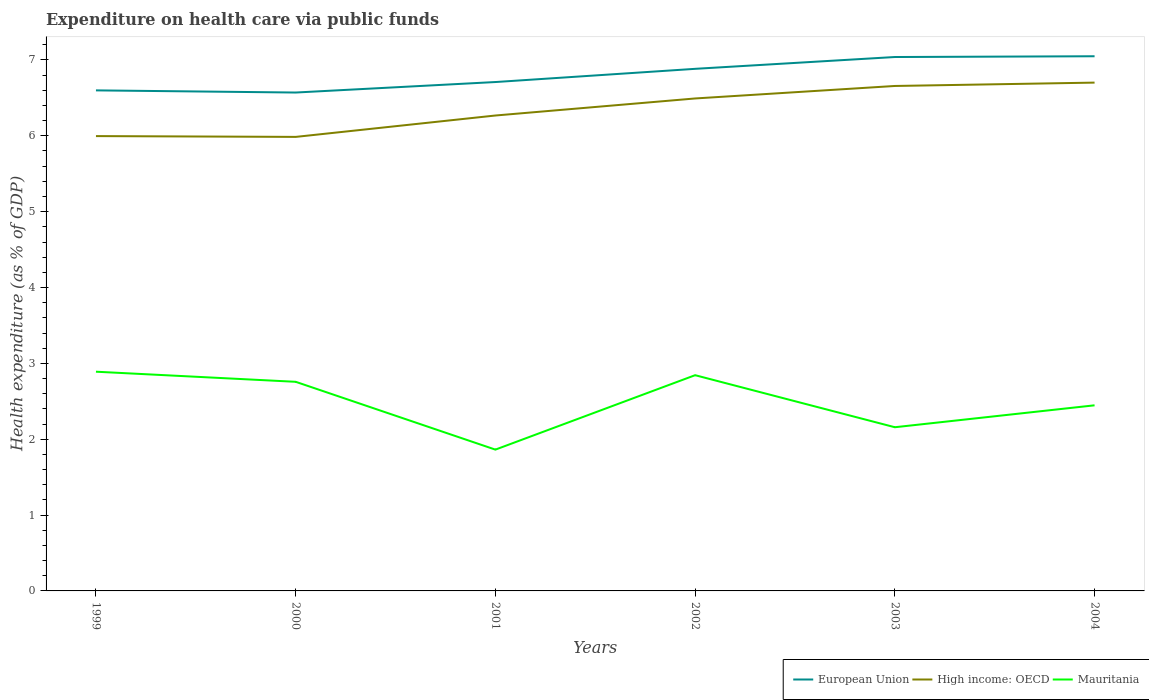How many different coloured lines are there?
Make the answer very short. 3. Does the line corresponding to Mauritania intersect with the line corresponding to European Union?
Provide a short and direct response. No. Across all years, what is the maximum expenditure made on health care in Mauritania?
Ensure brevity in your answer.  1.86. In which year was the expenditure made on health care in Mauritania maximum?
Your answer should be compact. 2001. What is the total expenditure made on health care in Mauritania in the graph?
Offer a terse response. 0.4. What is the difference between the highest and the second highest expenditure made on health care in European Union?
Provide a succinct answer. 0.48. Is the expenditure made on health care in High income: OECD strictly greater than the expenditure made on health care in Mauritania over the years?
Your response must be concise. No. How many years are there in the graph?
Make the answer very short. 6. What is the difference between two consecutive major ticks on the Y-axis?
Your response must be concise. 1. Are the values on the major ticks of Y-axis written in scientific E-notation?
Ensure brevity in your answer.  No. How many legend labels are there?
Keep it short and to the point. 3. How are the legend labels stacked?
Make the answer very short. Horizontal. What is the title of the graph?
Give a very brief answer. Expenditure on health care via public funds. What is the label or title of the Y-axis?
Your answer should be very brief. Health expenditure (as % of GDP). What is the Health expenditure (as % of GDP) of European Union in 1999?
Your answer should be very brief. 6.6. What is the Health expenditure (as % of GDP) of High income: OECD in 1999?
Your answer should be very brief. 6. What is the Health expenditure (as % of GDP) of Mauritania in 1999?
Offer a terse response. 2.89. What is the Health expenditure (as % of GDP) in European Union in 2000?
Your answer should be compact. 6.57. What is the Health expenditure (as % of GDP) in High income: OECD in 2000?
Offer a very short reply. 5.99. What is the Health expenditure (as % of GDP) in Mauritania in 2000?
Make the answer very short. 2.76. What is the Health expenditure (as % of GDP) in European Union in 2001?
Ensure brevity in your answer.  6.71. What is the Health expenditure (as % of GDP) of High income: OECD in 2001?
Make the answer very short. 6.27. What is the Health expenditure (as % of GDP) in Mauritania in 2001?
Offer a terse response. 1.86. What is the Health expenditure (as % of GDP) of European Union in 2002?
Make the answer very short. 6.88. What is the Health expenditure (as % of GDP) in High income: OECD in 2002?
Your response must be concise. 6.49. What is the Health expenditure (as % of GDP) in Mauritania in 2002?
Your answer should be compact. 2.84. What is the Health expenditure (as % of GDP) of European Union in 2003?
Provide a succinct answer. 7.04. What is the Health expenditure (as % of GDP) in High income: OECD in 2003?
Your response must be concise. 6.66. What is the Health expenditure (as % of GDP) in Mauritania in 2003?
Provide a short and direct response. 2.16. What is the Health expenditure (as % of GDP) in European Union in 2004?
Ensure brevity in your answer.  7.05. What is the Health expenditure (as % of GDP) in High income: OECD in 2004?
Offer a very short reply. 6.7. What is the Health expenditure (as % of GDP) of Mauritania in 2004?
Give a very brief answer. 2.45. Across all years, what is the maximum Health expenditure (as % of GDP) of European Union?
Your response must be concise. 7.05. Across all years, what is the maximum Health expenditure (as % of GDP) of High income: OECD?
Your answer should be very brief. 6.7. Across all years, what is the maximum Health expenditure (as % of GDP) in Mauritania?
Offer a very short reply. 2.89. Across all years, what is the minimum Health expenditure (as % of GDP) of European Union?
Offer a terse response. 6.57. Across all years, what is the minimum Health expenditure (as % of GDP) of High income: OECD?
Give a very brief answer. 5.99. Across all years, what is the minimum Health expenditure (as % of GDP) in Mauritania?
Provide a succinct answer. 1.86. What is the total Health expenditure (as % of GDP) in European Union in the graph?
Your response must be concise. 40.85. What is the total Health expenditure (as % of GDP) in High income: OECD in the graph?
Ensure brevity in your answer.  38.1. What is the total Health expenditure (as % of GDP) in Mauritania in the graph?
Ensure brevity in your answer.  14.96. What is the difference between the Health expenditure (as % of GDP) in European Union in 1999 and that in 2000?
Offer a terse response. 0.03. What is the difference between the Health expenditure (as % of GDP) of High income: OECD in 1999 and that in 2000?
Provide a succinct answer. 0.01. What is the difference between the Health expenditure (as % of GDP) of Mauritania in 1999 and that in 2000?
Give a very brief answer. 0.13. What is the difference between the Health expenditure (as % of GDP) of European Union in 1999 and that in 2001?
Offer a very short reply. -0.11. What is the difference between the Health expenditure (as % of GDP) in High income: OECD in 1999 and that in 2001?
Your answer should be compact. -0.27. What is the difference between the Health expenditure (as % of GDP) of Mauritania in 1999 and that in 2001?
Provide a short and direct response. 1.03. What is the difference between the Health expenditure (as % of GDP) in European Union in 1999 and that in 2002?
Offer a terse response. -0.28. What is the difference between the Health expenditure (as % of GDP) in High income: OECD in 1999 and that in 2002?
Your answer should be very brief. -0.5. What is the difference between the Health expenditure (as % of GDP) of Mauritania in 1999 and that in 2002?
Offer a terse response. 0.05. What is the difference between the Health expenditure (as % of GDP) of European Union in 1999 and that in 2003?
Your answer should be very brief. -0.44. What is the difference between the Health expenditure (as % of GDP) of High income: OECD in 1999 and that in 2003?
Your answer should be very brief. -0.66. What is the difference between the Health expenditure (as % of GDP) of Mauritania in 1999 and that in 2003?
Make the answer very short. 0.73. What is the difference between the Health expenditure (as % of GDP) of European Union in 1999 and that in 2004?
Ensure brevity in your answer.  -0.45. What is the difference between the Health expenditure (as % of GDP) of High income: OECD in 1999 and that in 2004?
Your response must be concise. -0.71. What is the difference between the Health expenditure (as % of GDP) of Mauritania in 1999 and that in 2004?
Make the answer very short. 0.44. What is the difference between the Health expenditure (as % of GDP) in European Union in 2000 and that in 2001?
Offer a very short reply. -0.14. What is the difference between the Health expenditure (as % of GDP) in High income: OECD in 2000 and that in 2001?
Make the answer very short. -0.28. What is the difference between the Health expenditure (as % of GDP) in Mauritania in 2000 and that in 2001?
Provide a short and direct response. 0.89. What is the difference between the Health expenditure (as % of GDP) of European Union in 2000 and that in 2002?
Your answer should be very brief. -0.31. What is the difference between the Health expenditure (as % of GDP) of High income: OECD in 2000 and that in 2002?
Ensure brevity in your answer.  -0.51. What is the difference between the Health expenditure (as % of GDP) of Mauritania in 2000 and that in 2002?
Provide a succinct answer. -0.09. What is the difference between the Health expenditure (as % of GDP) in European Union in 2000 and that in 2003?
Give a very brief answer. -0.47. What is the difference between the Health expenditure (as % of GDP) of High income: OECD in 2000 and that in 2003?
Keep it short and to the point. -0.67. What is the difference between the Health expenditure (as % of GDP) of Mauritania in 2000 and that in 2003?
Offer a very short reply. 0.6. What is the difference between the Health expenditure (as % of GDP) of European Union in 2000 and that in 2004?
Offer a very short reply. -0.48. What is the difference between the Health expenditure (as % of GDP) in High income: OECD in 2000 and that in 2004?
Give a very brief answer. -0.72. What is the difference between the Health expenditure (as % of GDP) in Mauritania in 2000 and that in 2004?
Offer a terse response. 0.31. What is the difference between the Health expenditure (as % of GDP) of European Union in 2001 and that in 2002?
Ensure brevity in your answer.  -0.17. What is the difference between the Health expenditure (as % of GDP) of High income: OECD in 2001 and that in 2002?
Provide a short and direct response. -0.22. What is the difference between the Health expenditure (as % of GDP) of Mauritania in 2001 and that in 2002?
Ensure brevity in your answer.  -0.98. What is the difference between the Health expenditure (as % of GDP) of European Union in 2001 and that in 2003?
Ensure brevity in your answer.  -0.33. What is the difference between the Health expenditure (as % of GDP) of High income: OECD in 2001 and that in 2003?
Your answer should be compact. -0.39. What is the difference between the Health expenditure (as % of GDP) of Mauritania in 2001 and that in 2003?
Your response must be concise. -0.29. What is the difference between the Health expenditure (as % of GDP) in European Union in 2001 and that in 2004?
Keep it short and to the point. -0.34. What is the difference between the Health expenditure (as % of GDP) of High income: OECD in 2001 and that in 2004?
Your answer should be compact. -0.43. What is the difference between the Health expenditure (as % of GDP) in Mauritania in 2001 and that in 2004?
Ensure brevity in your answer.  -0.58. What is the difference between the Health expenditure (as % of GDP) of European Union in 2002 and that in 2003?
Give a very brief answer. -0.16. What is the difference between the Health expenditure (as % of GDP) of High income: OECD in 2002 and that in 2003?
Keep it short and to the point. -0.16. What is the difference between the Health expenditure (as % of GDP) of Mauritania in 2002 and that in 2003?
Provide a succinct answer. 0.69. What is the difference between the Health expenditure (as % of GDP) of European Union in 2002 and that in 2004?
Give a very brief answer. -0.17. What is the difference between the Health expenditure (as % of GDP) of High income: OECD in 2002 and that in 2004?
Your answer should be compact. -0.21. What is the difference between the Health expenditure (as % of GDP) in Mauritania in 2002 and that in 2004?
Offer a very short reply. 0.4. What is the difference between the Health expenditure (as % of GDP) in European Union in 2003 and that in 2004?
Your answer should be compact. -0.01. What is the difference between the Health expenditure (as % of GDP) of High income: OECD in 2003 and that in 2004?
Give a very brief answer. -0.04. What is the difference between the Health expenditure (as % of GDP) in Mauritania in 2003 and that in 2004?
Provide a short and direct response. -0.29. What is the difference between the Health expenditure (as % of GDP) of European Union in 1999 and the Health expenditure (as % of GDP) of High income: OECD in 2000?
Your answer should be compact. 0.61. What is the difference between the Health expenditure (as % of GDP) in European Union in 1999 and the Health expenditure (as % of GDP) in Mauritania in 2000?
Offer a terse response. 3.84. What is the difference between the Health expenditure (as % of GDP) in High income: OECD in 1999 and the Health expenditure (as % of GDP) in Mauritania in 2000?
Make the answer very short. 3.24. What is the difference between the Health expenditure (as % of GDP) of European Union in 1999 and the Health expenditure (as % of GDP) of High income: OECD in 2001?
Your answer should be very brief. 0.33. What is the difference between the Health expenditure (as % of GDP) in European Union in 1999 and the Health expenditure (as % of GDP) in Mauritania in 2001?
Offer a terse response. 4.74. What is the difference between the Health expenditure (as % of GDP) of High income: OECD in 1999 and the Health expenditure (as % of GDP) of Mauritania in 2001?
Your answer should be very brief. 4.13. What is the difference between the Health expenditure (as % of GDP) in European Union in 1999 and the Health expenditure (as % of GDP) in High income: OECD in 2002?
Your response must be concise. 0.11. What is the difference between the Health expenditure (as % of GDP) of European Union in 1999 and the Health expenditure (as % of GDP) of Mauritania in 2002?
Ensure brevity in your answer.  3.75. What is the difference between the Health expenditure (as % of GDP) of High income: OECD in 1999 and the Health expenditure (as % of GDP) of Mauritania in 2002?
Your response must be concise. 3.15. What is the difference between the Health expenditure (as % of GDP) in European Union in 1999 and the Health expenditure (as % of GDP) in High income: OECD in 2003?
Provide a succinct answer. -0.06. What is the difference between the Health expenditure (as % of GDP) in European Union in 1999 and the Health expenditure (as % of GDP) in Mauritania in 2003?
Make the answer very short. 4.44. What is the difference between the Health expenditure (as % of GDP) of High income: OECD in 1999 and the Health expenditure (as % of GDP) of Mauritania in 2003?
Make the answer very short. 3.84. What is the difference between the Health expenditure (as % of GDP) of European Union in 1999 and the Health expenditure (as % of GDP) of High income: OECD in 2004?
Provide a short and direct response. -0.1. What is the difference between the Health expenditure (as % of GDP) of European Union in 1999 and the Health expenditure (as % of GDP) of Mauritania in 2004?
Provide a succinct answer. 4.15. What is the difference between the Health expenditure (as % of GDP) in High income: OECD in 1999 and the Health expenditure (as % of GDP) in Mauritania in 2004?
Give a very brief answer. 3.55. What is the difference between the Health expenditure (as % of GDP) of European Union in 2000 and the Health expenditure (as % of GDP) of High income: OECD in 2001?
Offer a very short reply. 0.3. What is the difference between the Health expenditure (as % of GDP) in European Union in 2000 and the Health expenditure (as % of GDP) in Mauritania in 2001?
Your answer should be compact. 4.71. What is the difference between the Health expenditure (as % of GDP) in High income: OECD in 2000 and the Health expenditure (as % of GDP) in Mauritania in 2001?
Provide a short and direct response. 4.12. What is the difference between the Health expenditure (as % of GDP) in European Union in 2000 and the Health expenditure (as % of GDP) in High income: OECD in 2002?
Make the answer very short. 0.08. What is the difference between the Health expenditure (as % of GDP) in European Union in 2000 and the Health expenditure (as % of GDP) in Mauritania in 2002?
Provide a succinct answer. 3.73. What is the difference between the Health expenditure (as % of GDP) in High income: OECD in 2000 and the Health expenditure (as % of GDP) in Mauritania in 2002?
Offer a very short reply. 3.14. What is the difference between the Health expenditure (as % of GDP) of European Union in 2000 and the Health expenditure (as % of GDP) of High income: OECD in 2003?
Ensure brevity in your answer.  -0.09. What is the difference between the Health expenditure (as % of GDP) in European Union in 2000 and the Health expenditure (as % of GDP) in Mauritania in 2003?
Provide a succinct answer. 4.41. What is the difference between the Health expenditure (as % of GDP) of High income: OECD in 2000 and the Health expenditure (as % of GDP) of Mauritania in 2003?
Your response must be concise. 3.83. What is the difference between the Health expenditure (as % of GDP) in European Union in 2000 and the Health expenditure (as % of GDP) in High income: OECD in 2004?
Your answer should be very brief. -0.13. What is the difference between the Health expenditure (as % of GDP) in European Union in 2000 and the Health expenditure (as % of GDP) in Mauritania in 2004?
Provide a succinct answer. 4.12. What is the difference between the Health expenditure (as % of GDP) of High income: OECD in 2000 and the Health expenditure (as % of GDP) of Mauritania in 2004?
Provide a succinct answer. 3.54. What is the difference between the Health expenditure (as % of GDP) in European Union in 2001 and the Health expenditure (as % of GDP) in High income: OECD in 2002?
Ensure brevity in your answer.  0.22. What is the difference between the Health expenditure (as % of GDP) of European Union in 2001 and the Health expenditure (as % of GDP) of Mauritania in 2002?
Offer a terse response. 3.86. What is the difference between the Health expenditure (as % of GDP) in High income: OECD in 2001 and the Health expenditure (as % of GDP) in Mauritania in 2002?
Your response must be concise. 3.42. What is the difference between the Health expenditure (as % of GDP) of European Union in 2001 and the Health expenditure (as % of GDP) of High income: OECD in 2003?
Your answer should be very brief. 0.05. What is the difference between the Health expenditure (as % of GDP) of European Union in 2001 and the Health expenditure (as % of GDP) of Mauritania in 2003?
Provide a short and direct response. 4.55. What is the difference between the Health expenditure (as % of GDP) in High income: OECD in 2001 and the Health expenditure (as % of GDP) in Mauritania in 2003?
Offer a very short reply. 4.11. What is the difference between the Health expenditure (as % of GDP) of European Union in 2001 and the Health expenditure (as % of GDP) of High income: OECD in 2004?
Give a very brief answer. 0.01. What is the difference between the Health expenditure (as % of GDP) of European Union in 2001 and the Health expenditure (as % of GDP) of Mauritania in 2004?
Ensure brevity in your answer.  4.26. What is the difference between the Health expenditure (as % of GDP) of High income: OECD in 2001 and the Health expenditure (as % of GDP) of Mauritania in 2004?
Keep it short and to the point. 3.82. What is the difference between the Health expenditure (as % of GDP) in European Union in 2002 and the Health expenditure (as % of GDP) in High income: OECD in 2003?
Ensure brevity in your answer.  0.23. What is the difference between the Health expenditure (as % of GDP) of European Union in 2002 and the Health expenditure (as % of GDP) of Mauritania in 2003?
Your answer should be compact. 4.73. What is the difference between the Health expenditure (as % of GDP) in High income: OECD in 2002 and the Health expenditure (as % of GDP) in Mauritania in 2003?
Give a very brief answer. 4.33. What is the difference between the Health expenditure (as % of GDP) of European Union in 2002 and the Health expenditure (as % of GDP) of High income: OECD in 2004?
Provide a succinct answer. 0.18. What is the difference between the Health expenditure (as % of GDP) in European Union in 2002 and the Health expenditure (as % of GDP) in Mauritania in 2004?
Your answer should be compact. 4.44. What is the difference between the Health expenditure (as % of GDP) in High income: OECD in 2002 and the Health expenditure (as % of GDP) in Mauritania in 2004?
Provide a succinct answer. 4.05. What is the difference between the Health expenditure (as % of GDP) in European Union in 2003 and the Health expenditure (as % of GDP) in High income: OECD in 2004?
Your answer should be compact. 0.34. What is the difference between the Health expenditure (as % of GDP) in European Union in 2003 and the Health expenditure (as % of GDP) in Mauritania in 2004?
Give a very brief answer. 4.59. What is the difference between the Health expenditure (as % of GDP) in High income: OECD in 2003 and the Health expenditure (as % of GDP) in Mauritania in 2004?
Your response must be concise. 4.21. What is the average Health expenditure (as % of GDP) in European Union per year?
Offer a very short reply. 6.81. What is the average Health expenditure (as % of GDP) of High income: OECD per year?
Your answer should be very brief. 6.35. What is the average Health expenditure (as % of GDP) in Mauritania per year?
Your answer should be compact. 2.49. In the year 1999, what is the difference between the Health expenditure (as % of GDP) of European Union and Health expenditure (as % of GDP) of High income: OECD?
Your response must be concise. 0.6. In the year 1999, what is the difference between the Health expenditure (as % of GDP) of European Union and Health expenditure (as % of GDP) of Mauritania?
Your answer should be compact. 3.71. In the year 1999, what is the difference between the Health expenditure (as % of GDP) in High income: OECD and Health expenditure (as % of GDP) in Mauritania?
Provide a succinct answer. 3.11. In the year 2000, what is the difference between the Health expenditure (as % of GDP) of European Union and Health expenditure (as % of GDP) of High income: OECD?
Offer a terse response. 0.58. In the year 2000, what is the difference between the Health expenditure (as % of GDP) of European Union and Health expenditure (as % of GDP) of Mauritania?
Your answer should be very brief. 3.81. In the year 2000, what is the difference between the Health expenditure (as % of GDP) of High income: OECD and Health expenditure (as % of GDP) of Mauritania?
Your answer should be compact. 3.23. In the year 2001, what is the difference between the Health expenditure (as % of GDP) of European Union and Health expenditure (as % of GDP) of High income: OECD?
Your answer should be very brief. 0.44. In the year 2001, what is the difference between the Health expenditure (as % of GDP) in European Union and Health expenditure (as % of GDP) in Mauritania?
Keep it short and to the point. 4.85. In the year 2001, what is the difference between the Health expenditure (as % of GDP) of High income: OECD and Health expenditure (as % of GDP) of Mauritania?
Ensure brevity in your answer.  4.4. In the year 2002, what is the difference between the Health expenditure (as % of GDP) of European Union and Health expenditure (as % of GDP) of High income: OECD?
Give a very brief answer. 0.39. In the year 2002, what is the difference between the Health expenditure (as % of GDP) of European Union and Health expenditure (as % of GDP) of Mauritania?
Provide a short and direct response. 4.04. In the year 2002, what is the difference between the Health expenditure (as % of GDP) of High income: OECD and Health expenditure (as % of GDP) of Mauritania?
Give a very brief answer. 3.65. In the year 2003, what is the difference between the Health expenditure (as % of GDP) in European Union and Health expenditure (as % of GDP) in High income: OECD?
Offer a terse response. 0.38. In the year 2003, what is the difference between the Health expenditure (as % of GDP) in European Union and Health expenditure (as % of GDP) in Mauritania?
Provide a short and direct response. 4.88. In the year 2003, what is the difference between the Health expenditure (as % of GDP) of High income: OECD and Health expenditure (as % of GDP) of Mauritania?
Offer a terse response. 4.5. In the year 2004, what is the difference between the Health expenditure (as % of GDP) in European Union and Health expenditure (as % of GDP) in High income: OECD?
Give a very brief answer. 0.35. In the year 2004, what is the difference between the Health expenditure (as % of GDP) of European Union and Health expenditure (as % of GDP) of Mauritania?
Your answer should be compact. 4.6. In the year 2004, what is the difference between the Health expenditure (as % of GDP) of High income: OECD and Health expenditure (as % of GDP) of Mauritania?
Your response must be concise. 4.25. What is the ratio of the Health expenditure (as % of GDP) of European Union in 1999 to that in 2000?
Offer a terse response. 1. What is the ratio of the Health expenditure (as % of GDP) of Mauritania in 1999 to that in 2000?
Your answer should be very brief. 1.05. What is the ratio of the Health expenditure (as % of GDP) of European Union in 1999 to that in 2001?
Provide a short and direct response. 0.98. What is the ratio of the Health expenditure (as % of GDP) in High income: OECD in 1999 to that in 2001?
Your answer should be very brief. 0.96. What is the ratio of the Health expenditure (as % of GDP) of Mauritania in 1999 to that in 2001?
Provide a short and direct response. 1.55. What is the ratio of the Health expenditure (as % of GDP) of European Union in 1999 to that in 2002?
Offer a terse response. 0.96. What is the ratio of the Health expenditure (as % of GDP) of High income: OECD in 1999 to that in 2002?
Provide a short and direct response. 0.92. What is the ratio of the Health expenditure (as % of GDP) of Mauritania in 1999 to that in 2002?
Offer a terse response. 1.02. What is the ratio of the Health expenditure (as % of GDP) of European Union in 1999 to that in 2003?
Offer a terse response. 0.94. What is the ratio of the Health expenditure (as % of GDP) in High income: OECD in 1999 to that in 2003?
Your response must be concise. 0.9. What is the ratio of the Health expenditure (as % of GDP) of Mauritania in 1999 to that in 2003?
Give a very brief answer. 1.34. What is the ratio of the Health expenditure (as % of GDP) in European Union in 1999 to that in 2004?
Provide a succinct answer. 0.94. What is the ratio of the Health expenditure (as % of GDP) in High income: OECD in 1999 to that in 2004?
Keep it short and to the point. 0.89. What is the ratio of the Health expenditure (as % of GDP) of Mauritania in 1999 to that in 2004?
Offer a very short reply. 1.18. What is the ratio of the Health expenditure (as % of GDP) in European Union in 2000 to that in 2001?
Provide a short and direct response. 0.98. What is the ratio of the Health expenditure (as % of GDP) in High income: OECD in 2000 to that in 2001?
Ensure brevity in your answer.  0.95. What is the ratio of the Health expenditure (as % of GDP) of Mauritania in 2000 to that in 2001?
Make the answer very short. 1.48. What is the ratio of the Health expenditure (as % of GDP) of European Union in 2000 to that in 2002?
Provide a short and direct response. 0.95. What is the ratio of the Health expenditure (as % of GDP) in High income: OECD in 2000 to that in 2002?
Provide a succinct answer. 0.92. What is the ratio of the Health expenditure (as % of GDP) in Mauritania in 2000 to that in 2002?
Provide a succinct answer. 0.97. What is the ratio of the Health expenditure (as % of GDP) in European Union in 2000 to that in 2003?
Your response must be concise. 0.93. What is the ratio of the Health expenditure (as % of GDP) of High income: OECD in 2000 to that in 2003?
Provide a short and direct response. 0.9. What is the ratio of the Health expenditure (as % of GDP) in Mauritania in 2000 to that in 2003?
Make the answer very short. 1.28. What is the ratio of the Health expenditure (as % of GDP) of European Union in 2000 to that in 2004?
Your answer should be compact. 0.93. What is the ratio of the Health expenditure (as % of GDP) in High income: OECD in 2000 to that in 2004?
Keep it short and to the point. 0.89. What is the ratio of the Health expenditure (as % of GDP) in Mauritania in 2000 to that in 2004?
Your answer should be very brief. 1.13. What is the ratio of the Health expenditure (as % of GDP) of European Union in 2001 to that in 2002?
Offer a terse response. 0.97. What is the ratio of the Health expenditure (as % of GDP) of High income: OECD in 2001 to that in 2002?
Your answer should be compact. 0.97. What is the ratio of the Health expenditure (as % of GDP) in Mauritania in 2001 to that in 2002?
Make the answer very short. 0.66. What is the ratio of the Health expenditure (as % of GDP) of European Union in 2001 to that in 2003?
Your response must be concise. 0.95. What is the ratio of the Health expenditure (as % of GDP) of High income: OECD in 2001 to that in 2003?
Make the answer very short. 0.94. What is the ratio of the Health expenditure (as % of GDP) in Mauritania in 2001 to that in 2003?
Offer a very short reply. 0.86. What is the ratio of the Health expenditure (as % of GDP) of European Union in 2001 to that in 2004?
Offer a very short reply. 0.95. What is the ratio of the Health expenditure (as % of GDP) in High income: OECD in 2001 to that in 2004?
Your answer should be compact. 0.94. What is the ratio of the Health expenditure (as % of GDP) of Mauritania in 2001 to that in 2004?
Offer a terse response. 0.76. What is the ratio of the Health expenditure (as % of GDP) in European Union in 2002 to that in 2003?
Give a very brief answer. 0.98. What is the ratio of the Health expenditure (as % of GDP) of High income: OECD in 2002 to that in 2003?
Offer a very short reply. 0.98. What is the ratio of the Health expenditure (as % of GDP) of Mauritania in 2002 to that in 2003?
Make the answer very short. 1.32. What is the ratio of the Health expenditure (as % of GDP) in European Union in 2002 to that in 2004?
Make the answer very short. 0.98. What is the ratio of the Health expenditure (as % of GDP) of High income: OECD in 2002 to that in 2004?
Your answer should be very brief. 0.97. What is the ratio of the Health expenditure (as % of GDP) in Mauritania in 2002 to that in 2004?
Your answer should be compact. 1.16. What is the ratio of the Health expenditure (as % of GDP) of High income: OECD in 2003 to that in 2004?
Your answer should be compact. 0.99. What is the ratio of the Health expenditure (as % of GDP) of Mauritania in 2003 to that in 2004?
Provide a succinct answer. 0.88. What is the difference between the highest and the second highest Health expenditure (as % of GDP) in European Union?
Your answer should be compact. 0.01. What is the difference between the highest and the second highest Health expenditure (as % of GDP) in High income: OECD?
Offer a terse response. 0.04. What is the difference between the highest and the second highest Health expenditure (as % of GDP) of Mauritania?
Your response must be concise. 0.05. What is the difference between the highest and the lowest Health expenditure (as % of GDP) in European Union?
Your answer should be very brief. 0.48. What is the difference between the highest and the lowest Health expenditure (as % of GDP) of High income: OECD?
Offer a terse response. 0.72. What is the difference between the highest and the lowest Health expenditure (as % of GDP) in Mauritania?
Make the answer very short. 1.03. 